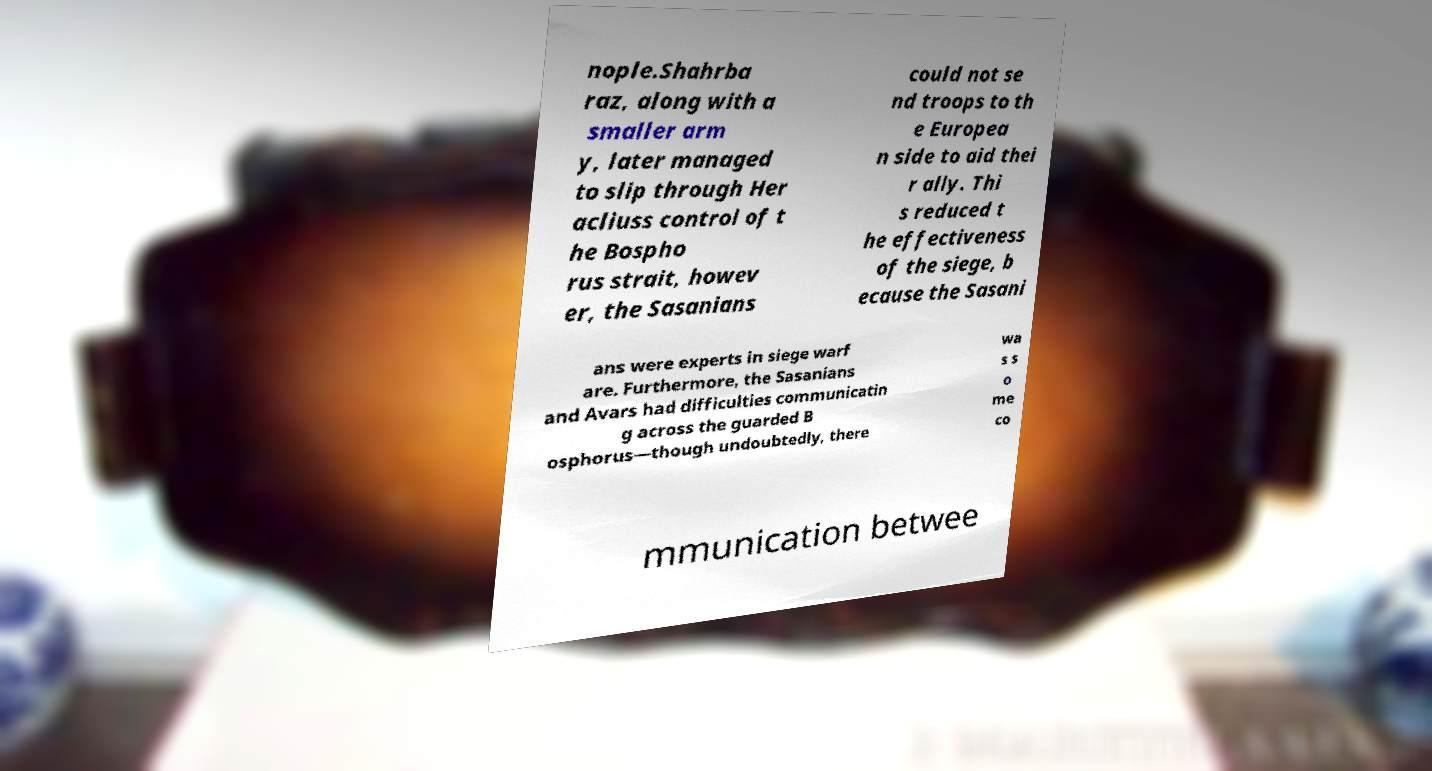I need the written content from this picture converted into text. Can you do that? nople.Shahrba raz, along with a smaller arm y, later managed to slip through Her acliuss control of t he Bospho rus strait, howev er, the Sasanians could not se nd troops to th e Europea n side to aid thei r ally. Thi s reduced t he effectiveness of the siege, b ecause the Sasani ans were experts in siege warf are. Furthermore, the Sasanians and Avars had difficulties communicatin g across the guarded B osphorus—though undoubtedly, there wa s s o me co mmunication betwee 